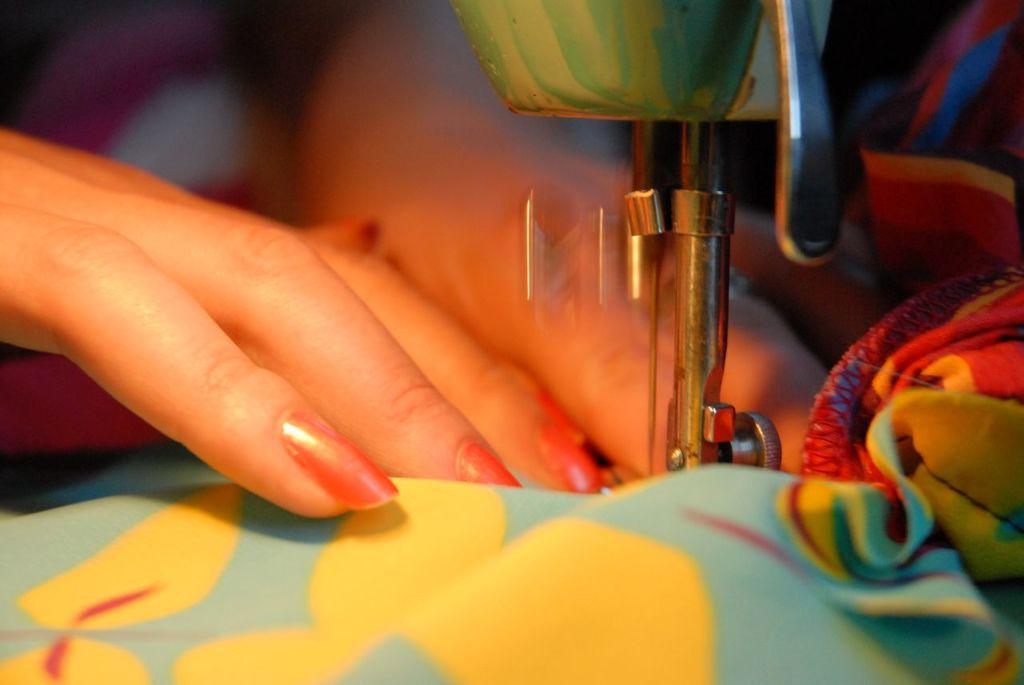Can you describe this image briefly? In this image I can see the person sewing the cloth with the machine. I can see the cloth is in yellow, blue and red color. To the side I can see the machine. And there is a blurred background. 